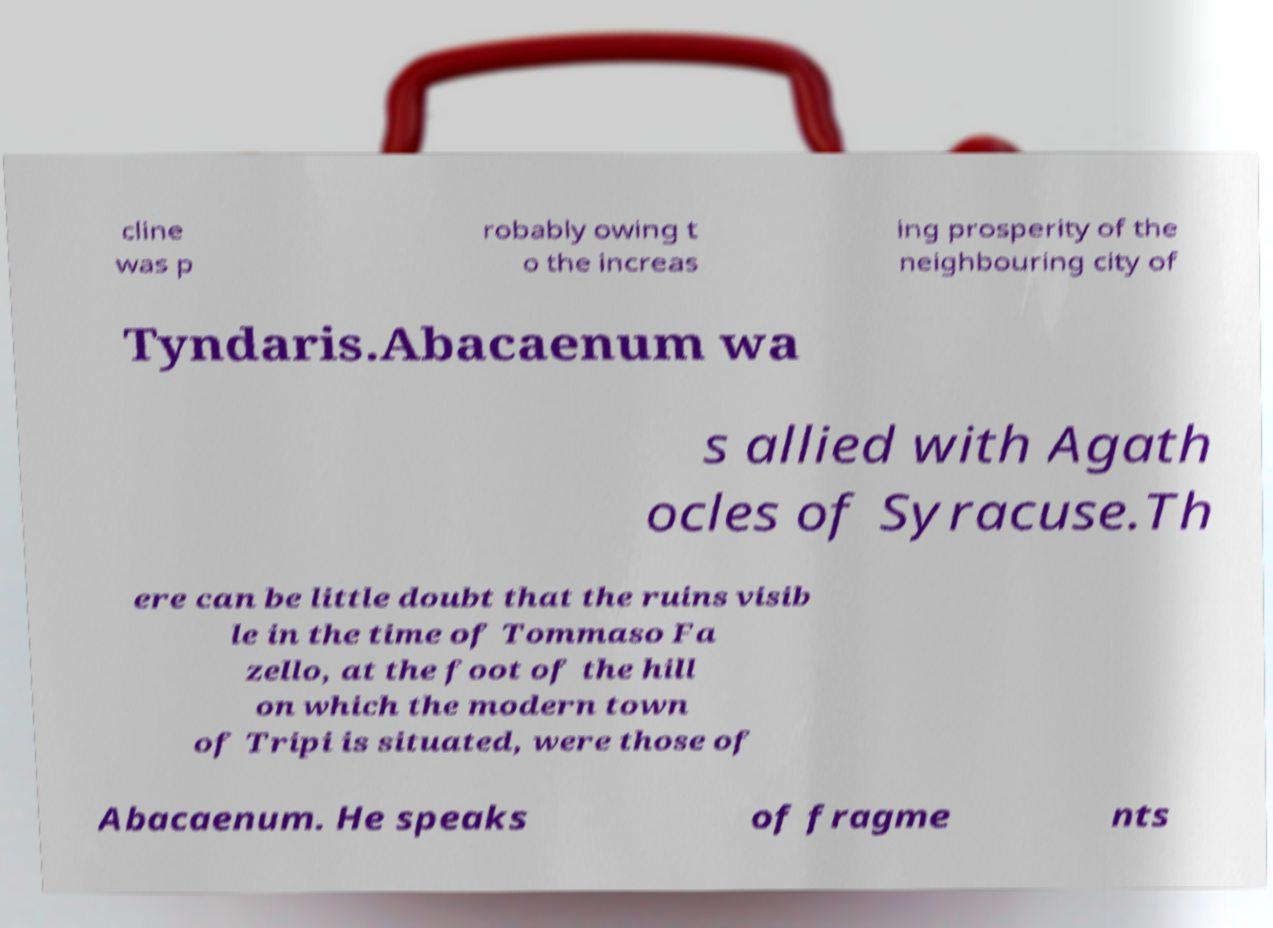Could you extract and type out the text from this image? cline was p robably owing t o the increas ing prosperity of the neighbouring city of Tyndaris.Abacaenum wa s allied with Agath ocles of Syracuse.Th ere can be little doubt that the ruins visib le in the time of Tommaso Fa zello, at the foot of the hill on which the modern town of Tripi is situated, were those of Abacaenum. He speaks of fragme nts 